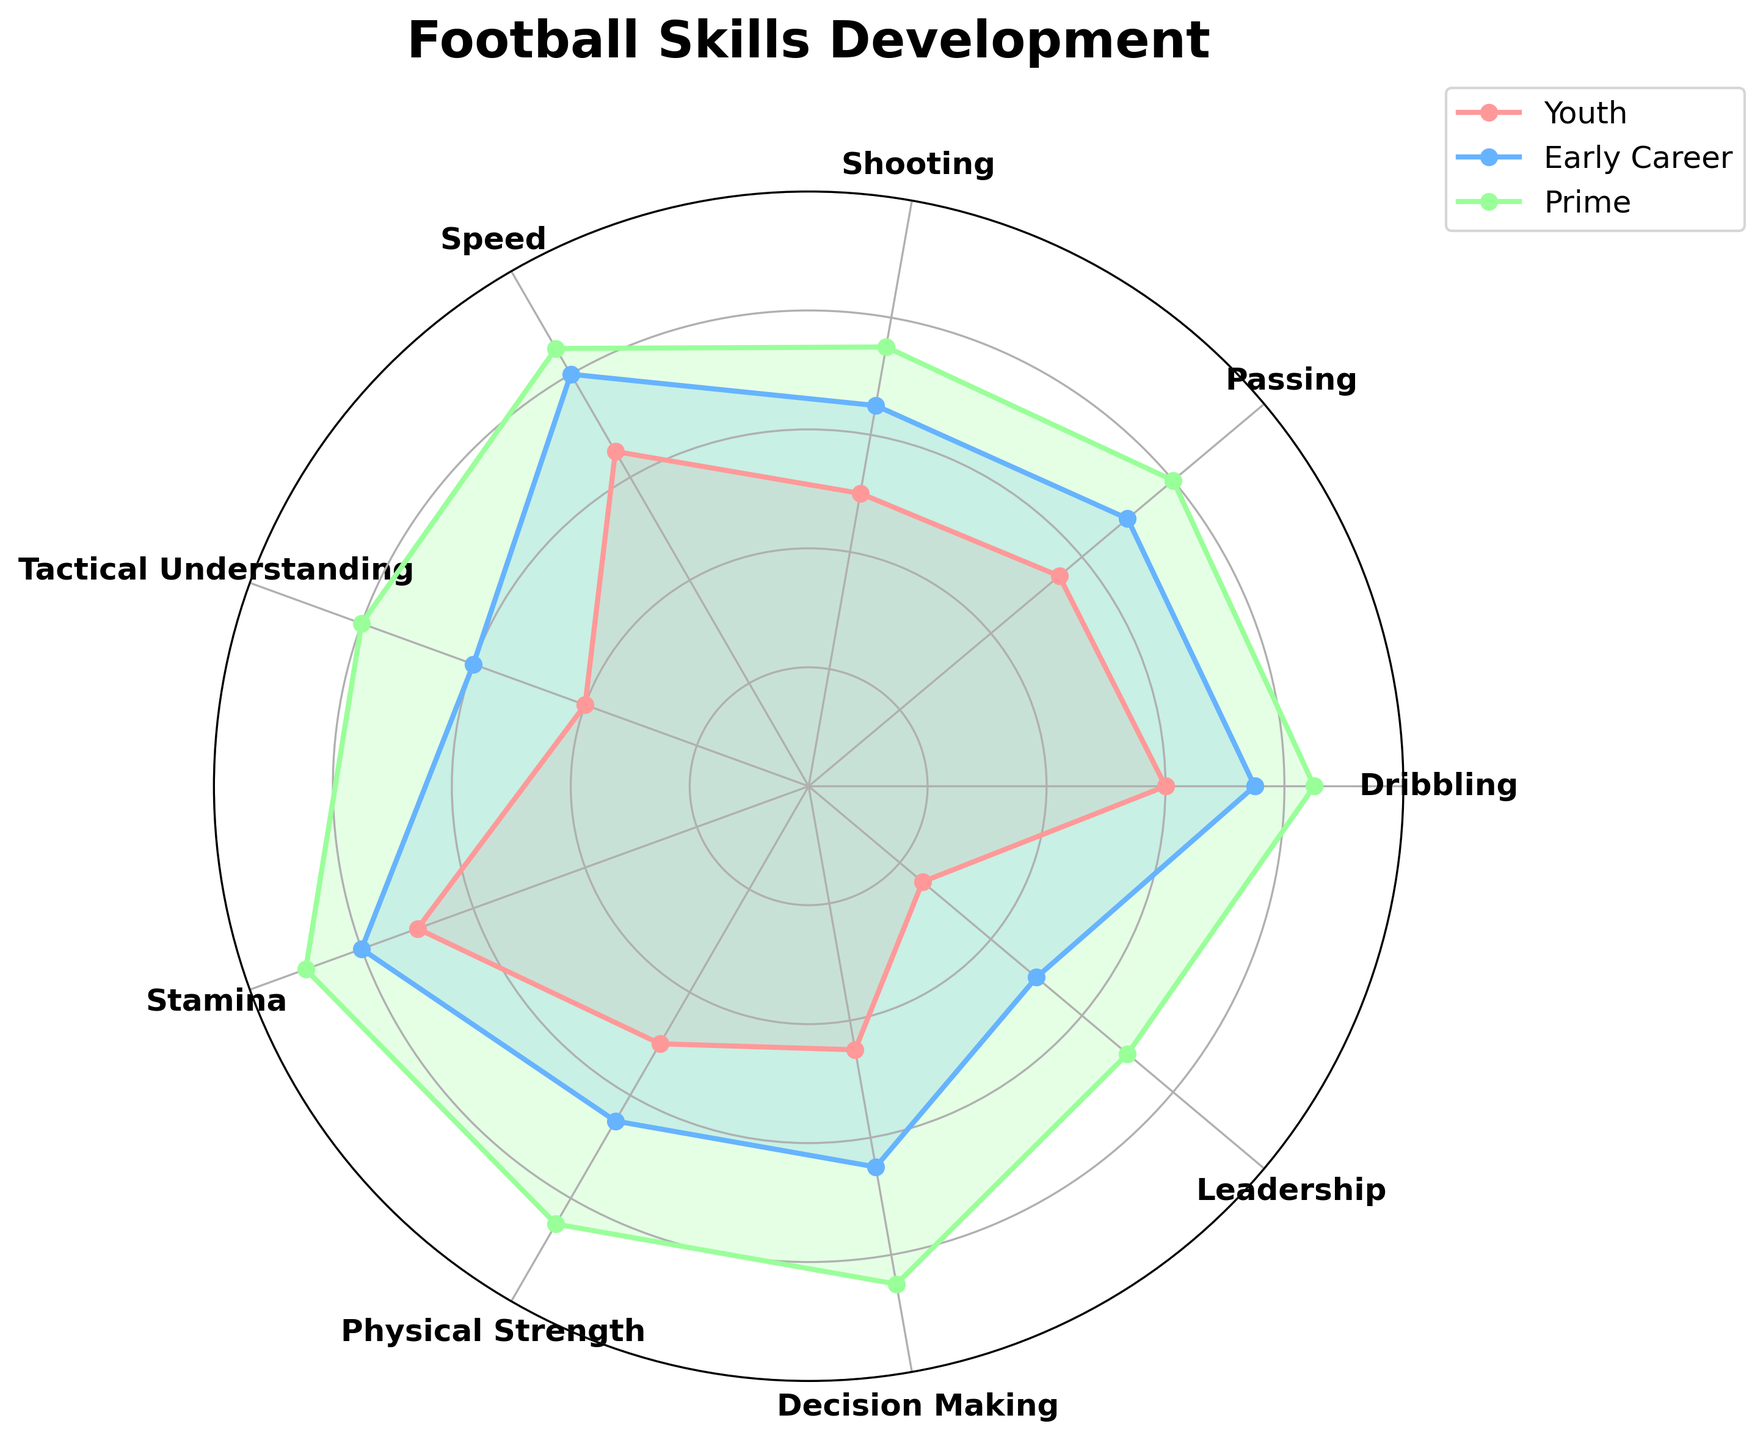Which skill shows the highest improvement from Youth to Prime? To find this, we look at each skill's values and calculate the difference between the Youth and Prime phases. Dribbling: 85-60=25, Passing: 80-55=25, Shooting: 75-50=25, Speed: 85-65=20, Tactical Understanding: 80-40=40, Stamina: 90-70=20, Physical Strength: 85-50=35, Decision Making: 85-45=40, Leadership: 70-25=45. The highest improvement is in Leadership.
Answer: Leadership Which phase has the highest average skill rating? Calculate the average for each phase. Youth: (60+55+50+65+40+70+50+45+25)/9 = 51.11, Early Career: (75+70+65+80+60+80+65+65+50)/9 = 67.78, Prime: (85+80+75+85+80+90+85+85+70)/9 = 81.67. The phase with the highest average is Prime.
Answer: Prime What is the biggest difference in rating between any two skills in the Youth phase? Look at the Youth ratings: Dribbling: 60, Passing: 55, Shooting: 50, Speed: 65, Tactical Understanding: 40, Stamina: 70, Physical Strength: 50, Decision Making: 45, Leadership: 25. The biggest difference is between Stamina (70) and Leadership (25), which is 45.
Answer: 45 Which skill has a consistently high rating in all three phases? Check for skills with consistently high values: Dribbling (60, 75, 85), Speed (65, 80, 85), Stamina (70, 80, 90). Among these, Stamina has the highest and most consistent performance.
Answer: Stamina In which phase does Tactical Understanding show the most significant improvement? Calculate improvement per phase: Youth to Early Career: 60-40=20, Early Career to Prime: 80-60=20. The improvement is the same between both transitions.
Answer: Both transitions (20) Which skill shows the least variance between phases? Calculate the variance for each skill. Variance: Dribbling (variance: 108.3), Passing (variance: 108.3), Shooting (variance: 108.3), Speed (variance: 100), Tactical Understanding (variance: 266.7), Stamina (variance: 100), Physical Strength (variance: 291.7), Decision Making (variance: 311.1), Leadership (variance: 505.6). The skill with the lowest variance is Speed.
Answer: Speed What is the average rating for Physical Strength in all phases? Calculate the average: (50+65+85)/3 = 66.67.
Answer: 66.67 How much does Decision Making improve from Youth to Early Career? Calculate the difference: 65 - 45 = 20.
Answer: 20 